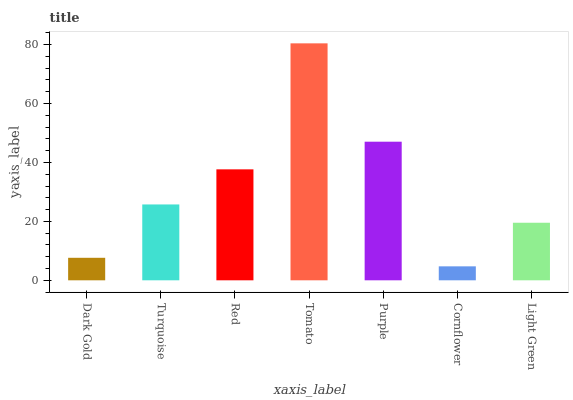Is Cornflower the minimum?
Answer yes or no. Yes. Is Tomato the maximum?
Answer yes or no. Yes. Is Turquoise the minimum?
Answer yes or no. No. Is Turquoise the maximum?
Answer yes or no. No. Is Turquoise greater than Dark Gold?
Answer yes or no. Yes. Is Dark Gold less than Turquoise?
Answer yes or no. Yes. Is Dark Gold greater than Turquoise?
Answer yes or no. No. Is Turquoise less than Dark Gold?
Answer yes or no. No. Is Turquoise the high median?
Answer yes or no. Yes. Is Turquoise the low median?
Answer yes or no. Yes. Is Dark Gold the high median?
Answer yes or no. No. Is Purple the low median?
Answer yes or no. No. 